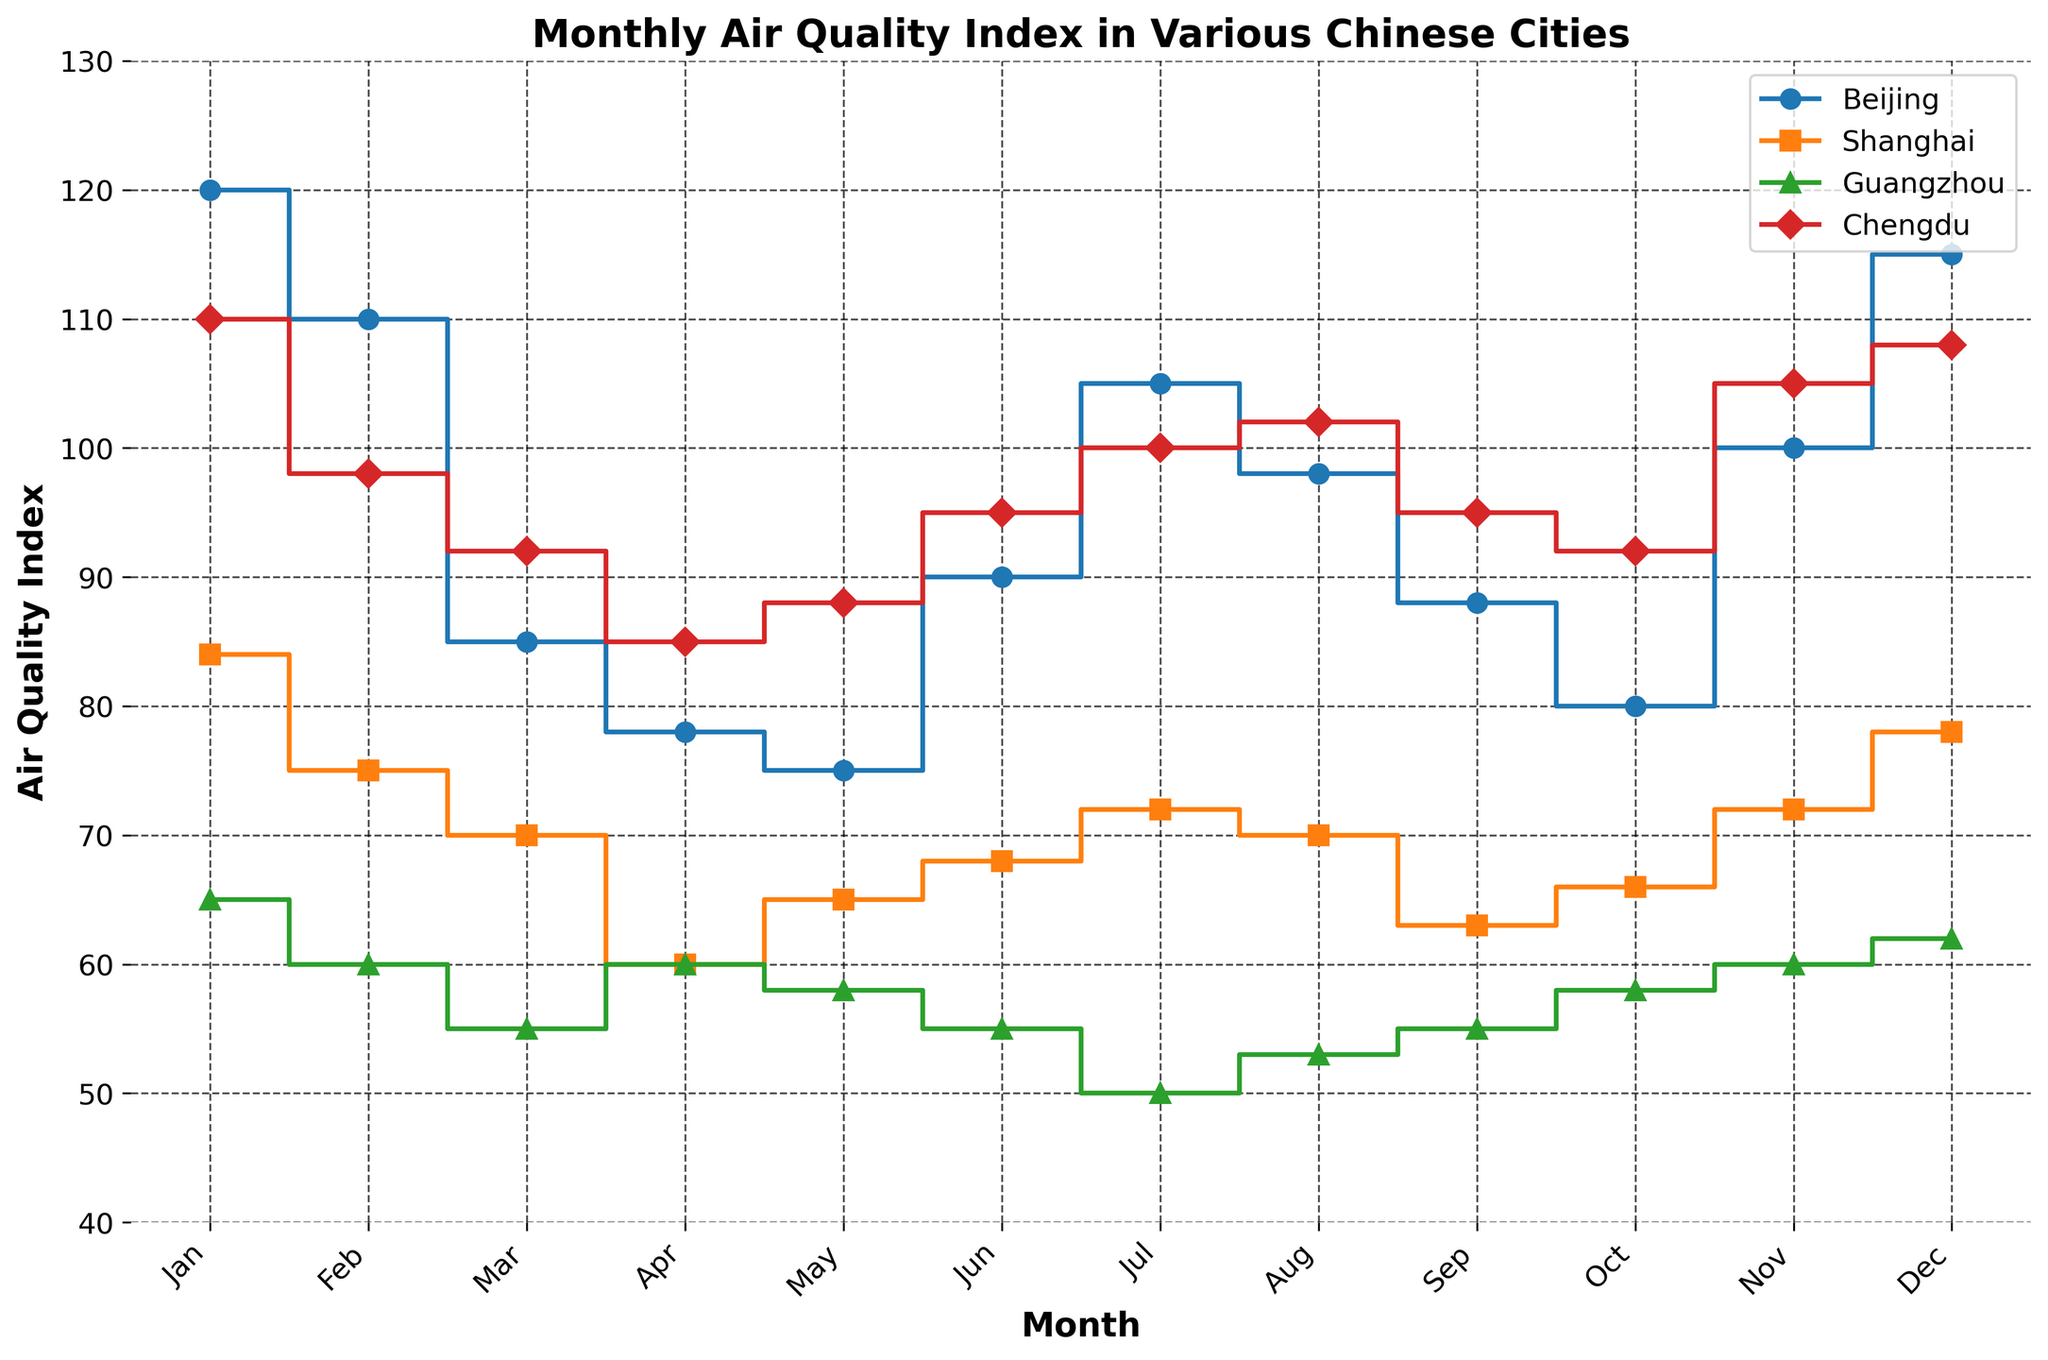When is the air quality index the highest for Beijing? By observing the stair lines for Beijing, the peak point is in January, where the value is highest.
Answer: January Which city has the lowest air quality index in July? Comparing the stair plots for all cities in July, Guangzhou has the lowest value, at 50.
Answer: Guangzhou How does the air quality index in September for Chengdu compare to Shanghai? In September, the air quality index for Chengdu is 95, while for Shanghai, it is 63. Chengdu's value is higher by 32 points.
Answer: Chengdu is higher by 32 points What is the title of the plot? The title is displayed prominently at the top of the plot.
Answer: Monthly Air Quality Index in Various Chinese Cities In which months does Guangzhou have an air quality index below 60? By looking at the stair plot for Guangzhou, the AQI is below 60 in March, April, June, July, September.
Answer: March, April, June, July, September What is the color of the line representing Beijing? The color for Beijing’s line is blue.
Answer: Blue Which city has the steepest increase in the air quality index from June to July? By comparing the slopes from June to July across all cities, Beijing shows the steepest increase, jumping from 90 to 105.
Answer: Beijing How many cities' data are shown in the plot? The legend at the top right corner of the plot lists all represented cities.
Answer: Four What is the range of the y-axis? The y-axis range can be observed from the scale starting at 40 and ending at 130.
Answer: 40 to 130 In which month does Beijing have an air quality index lower than 90? Observing the plot for Beijing, the AQI is lower than 90 in March, April, May, September, and October.
Answer: March, April, May, September, October 